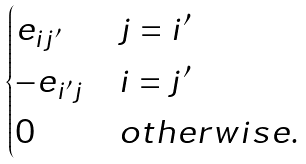Convert formula to latex. <formula><loc_0><loc_0><loc_500><loc_500>\begin{cases} e _ { i j ^ { \prime } } & j = i ^ { \prime } \\ - e _ { i ^ { \prime } j } & i = j ^ { \prime } \\ 0 & o t h e r w i s e . \end{cases}</formula> 